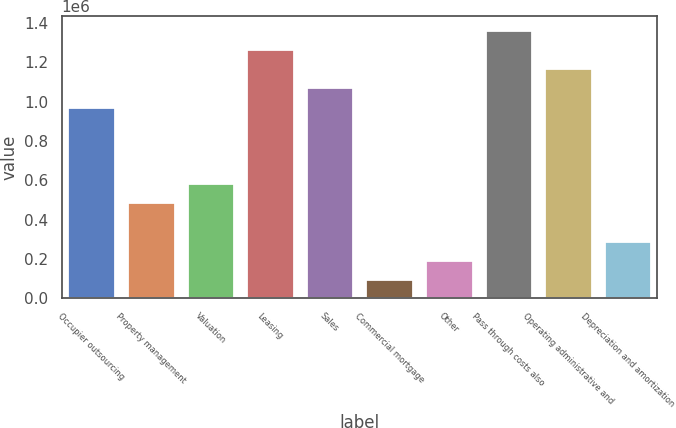<chart> <loc_0><loc_0><loc_500><loc_500><bar_chart><fcel>Occupier outsourcing<fcel>Property management<fcel>Valuation<fcel>Leasing<fcel>Sales<fcel>Commercial mortgage<fcel>Other<fcel>Pass through costs also<fcel>Operating administrative and<fcel>Depreciation and amortization<nl><fcel>974882<fcel>487658<fcel>585102<fcel>1.26722e+06<fcel>1.07233e+06<fcel>97877.9<fcel>195323<fcel>1.36466e+06<fcel>1.16977e+06<fcel>292768<nl></chart> 